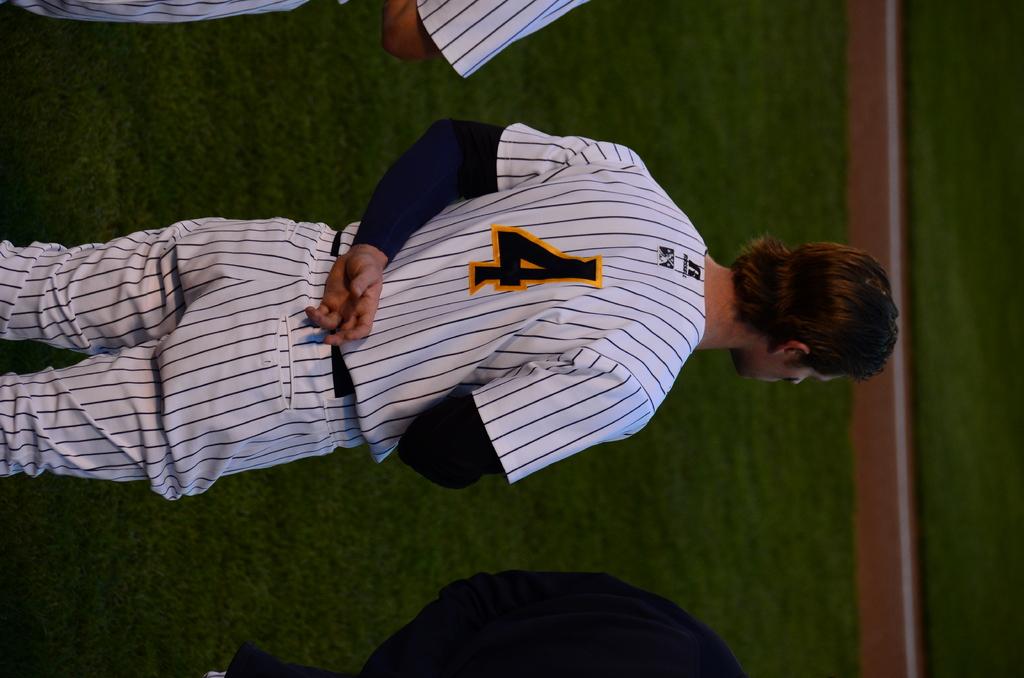What number is this player?
Your answer should be very brief. 4. What letter is at the very top of the back of his shirt?
Ensure brevity in your answer.  R. 